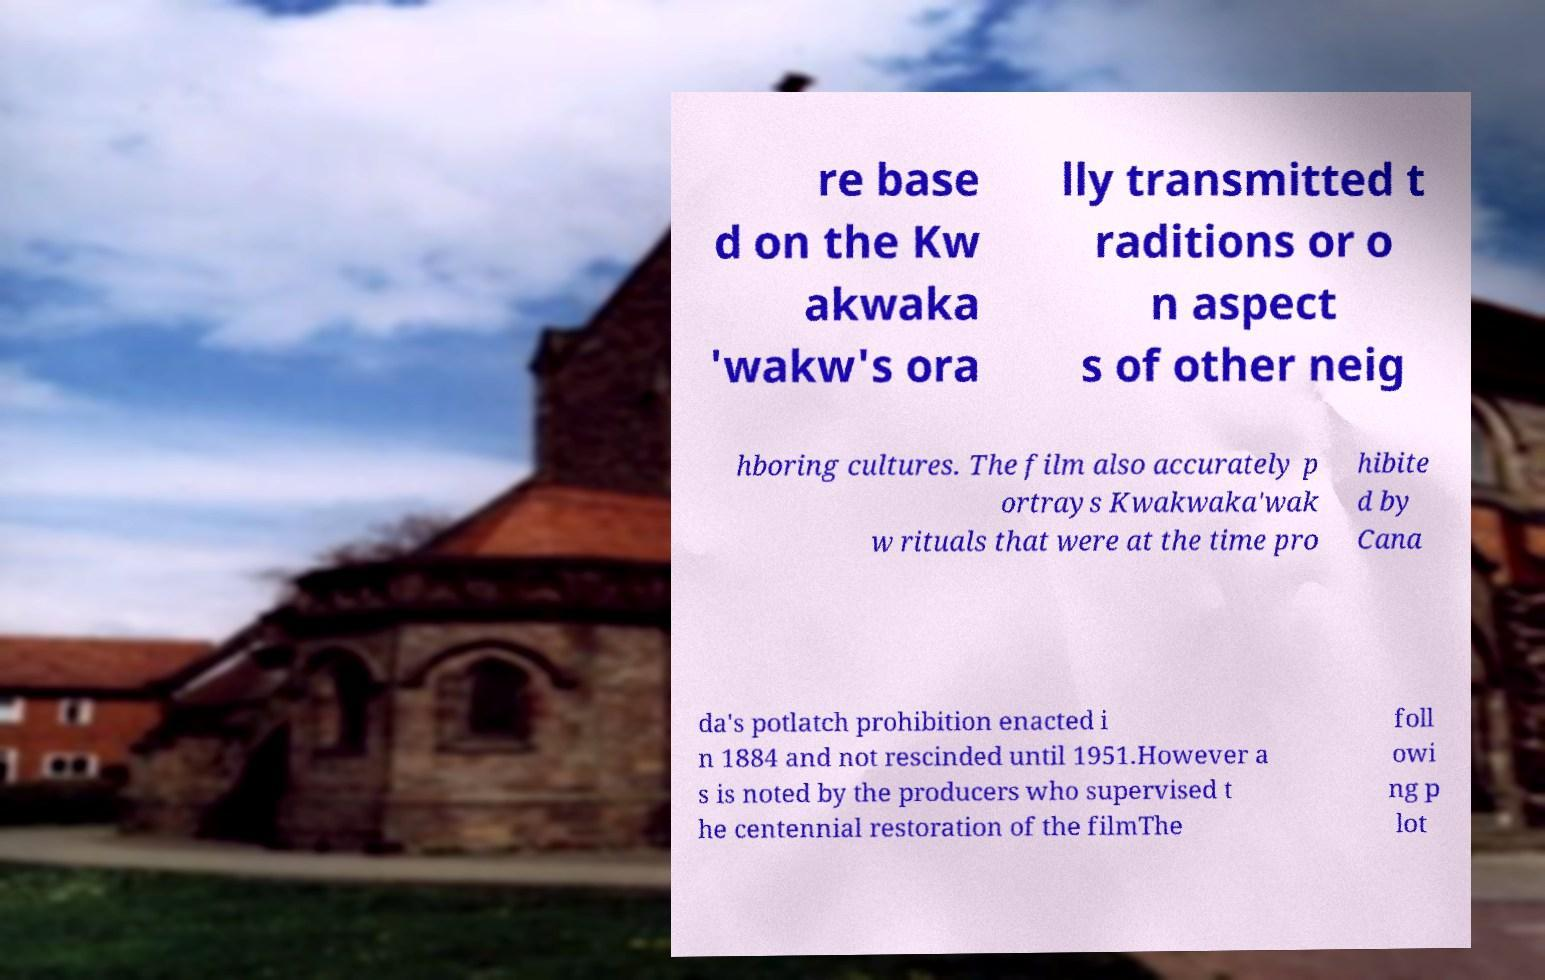Could you extract and type out the text from this image? re base d on the Kw akwaka 'wakw's ora lly transmitted t raditions or o n aspect s of other neig hboring cultures. The film also accurately p ortrays Kwakwaka'wak w rituals that were at the time pro hibite d by Cana da's potlatch prohibition enacted i n 1884 and not rescinded until 1951.However a s is noted by the producers who supervised t he centennial restoration of the filmThe foll owi ng p lot 